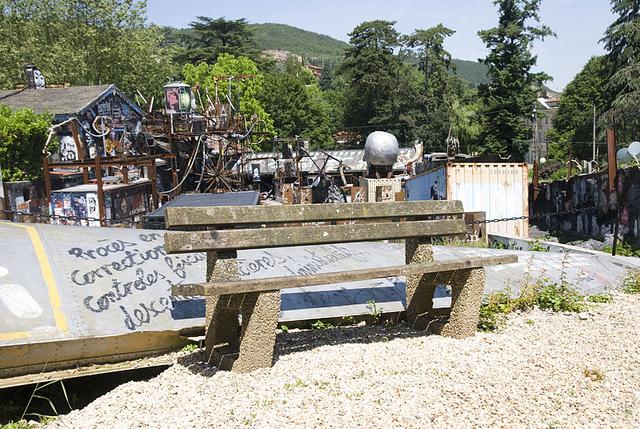Are there palm trees in the background?
Give a very brief answer. No. Is there graffiti?
Be succinct. Yes. Who is on the bench?
Keep it brief. No one. 